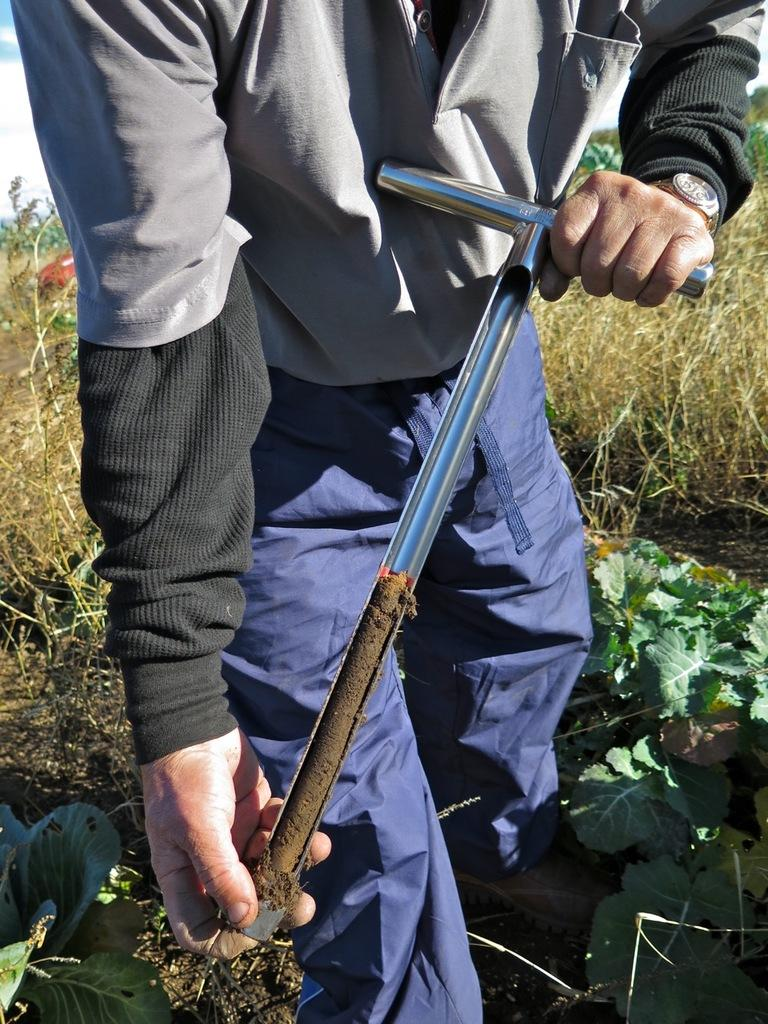What is the main subject of the image? There is a person standing in the image. What is the person holding in the image? The person is holding an equipment. What type of vegetation can be seen in the image? There are green color leaves and grass in the image. What type of copper is being sold at the market in the image? There is no market or copper present in the image; it features a person holding an equipment and green leaves. What role does the governor play in the image? There is no governor present in the image. 